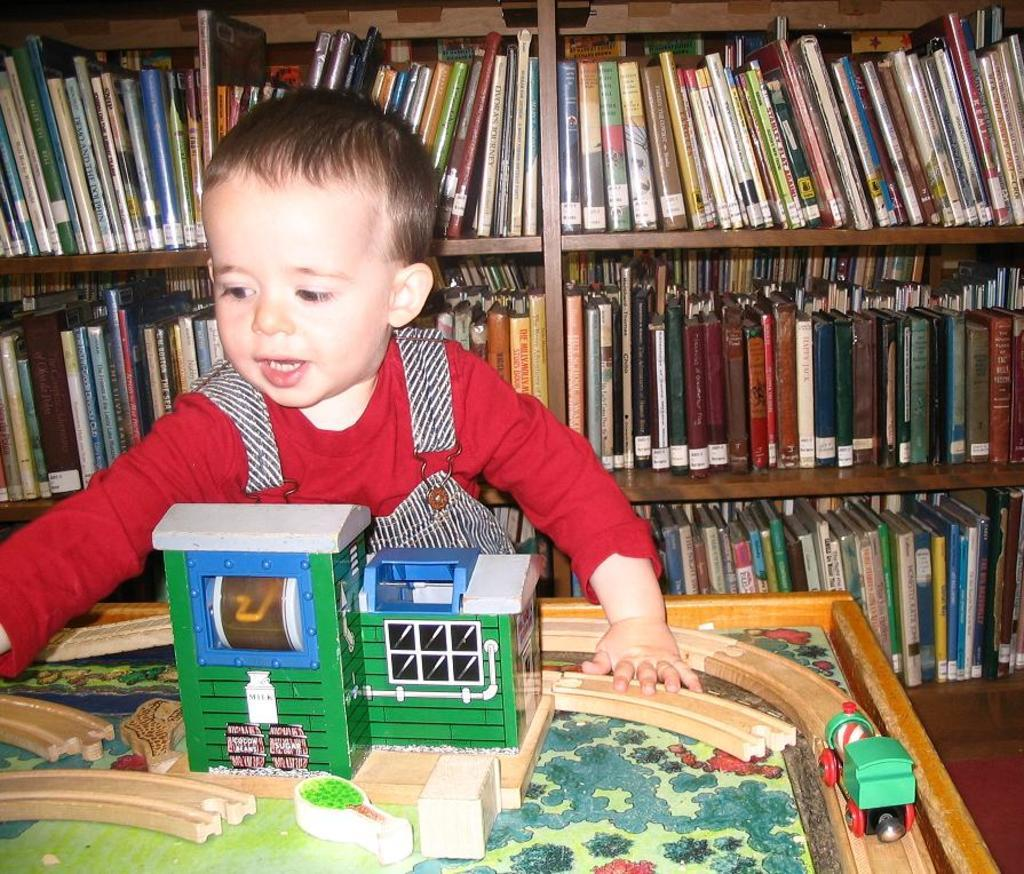What is the main subject of the image? There is a baby in the image. What is the baby sitting in front of? The baby is sitting in front of a board. What is depicted on the board? The board has a picture of a house on it. What can be seen behind the baby? There are shelves behind the baby. What items are on the shelves? The shelves contain books. Can you tell me how many bees are buzzing around the baby in the image? There are no bees present in the image; the focus is on the baby, the board, and the shelves with books. 